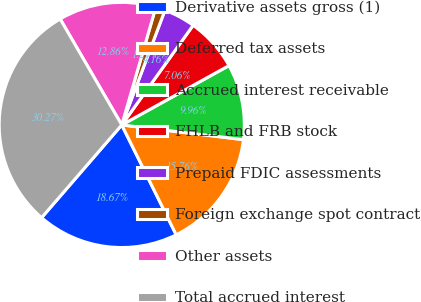<chart> <loc_0><loc_0><loc_500><loc_500><pie_chart><fcel>Derivative assets gross (1)<fcel>Deferred tax assets<fcel>Accrued interest receivable<fcel>FHLB and FRB stock<fcel>Prepaid FDIC assessments<fcel>Foreign exchange spot contract<fcel>Other assets<fcel>Total accrued interest<nl><fcel>18.67%<fcel>15.76%<fcel>9.96%<fcel>7.06%<fcel>4.16%<fcel>1.25%<fcel>12.86%<fcel>30.27%<nl></chart> 